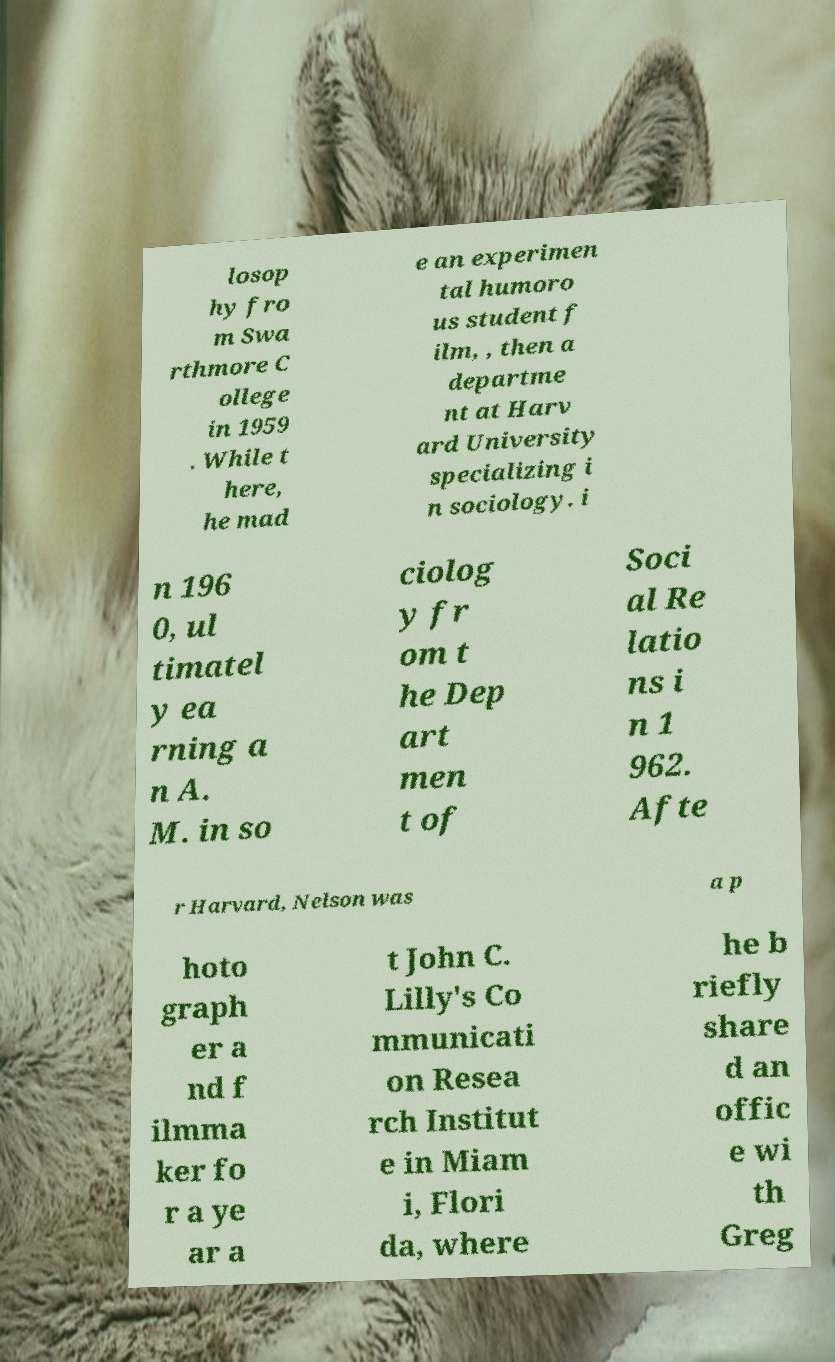What messages or text are displayed in this image? I need them in a readable, typed format. losop hy fro m Swa rthmore C ollege in 1959 . While t here, he mad e an experimen tal humoro us student f ilm, , then a departme nt at Harv ard University specializing i n sociology. i n 196 0, ul timatel y ea rning a n A. M. in so ciolog y fr om t he Dep art men t of Soci al Re latio ns i n 1 962. Afte r Harvard, Nelson was a p hoto graph er a nd f ilmma ker fo r a ye ar a t John C. Lilly's Co mmunicati on Resea rch Institut e in Miam i, Flori da, where he b riefly share d an offic e wi th Greg 